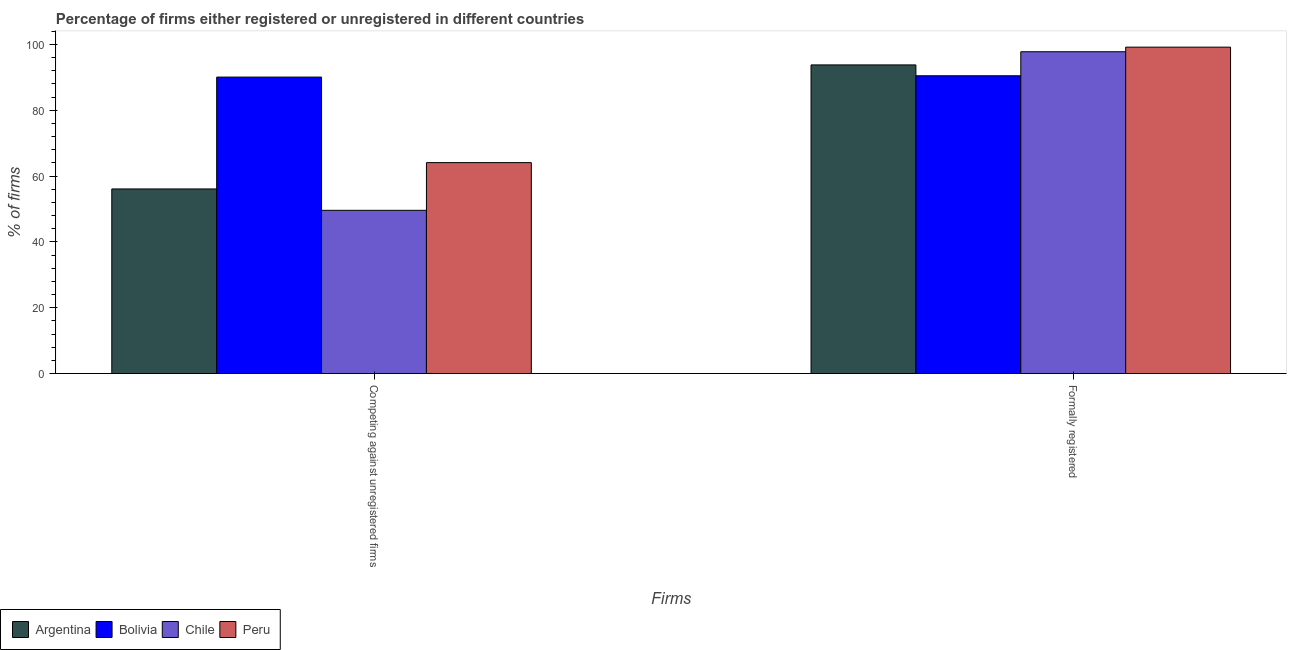How many different coloured bars are there?
Your answer should be very brief. 4. Are the number of bars per tick equal to the number of legend labels?
Your answer should be very brief. Yes. How many bars are there on the 1st tick from the right?
Give a very brief answer. 4. What is the label of the 1st group of bars from the left?
Offer a very short reply. Competing against unregistered firms. What is the percentage of formally registered firms in Argentina?
Give a very brief answer. 93.8. Across all countries, what is the maximum percentage of formally registered firms?
Provide a succinct answer. 99.2. Across all countries, what is the minimum percentage of registered firms?
Offer a terse response. 49.6. In which country was the percentage of formally registered firms maximum?
Ensure brevity in your answer.  Peru. What is the total percentage of formally registered firms in the graph?
Provide a succinct answer. 381.3. What is the difference between the percentage of formally registered firms in Bolivia and that in Chile?
Your response must be concise. -7.3. What is the difference between the percentage of registered firms in Argentina and the percentage of formally registered firms in Bolivia?
Your answer should be very brief. -34.4. What is the average percentage of registered firms per country?
Provide a succinct answer. 64.97. What is the difference between the percentage of registered firms and percentage of formally registered firms in Chile?
Offer a very short reply. -48.2. What is the ratio of the percentage of registered firms in Bolivia to that in Argentina?
Offer a very short reply. 1.61. Is the percentage of formally registered firms in Argentina less than that in Bolivia?
Keep it short and to the point. No. In how many countries, is the percentage of registered firms greater than the average percentage of registered firms taken over all countries?
Your answer should be very brief. 1. How many countries are there in the graph?
Ensure brevity in your answer.  4. What is the difference between two consecutive major ticks on the Y-axis?
Provide a short and direct response. 20. Does the graph contain any zero values?
Offer a terse response. No. Where does the legend appear in the graph?
Provide a short and direct response. Bottom left. How many legend labels are there?
Give a very brief answer. 4. What is the title of the graph?
Give a very brief answer. Percentage of firms either registered or unregistered in different countries. What is the label or title of the X-axis?
Give a very brief answer. Firms. What is the label or title of the Y-axis?
Ensure brevity in your answer.  % of firms. What is the % of firms in Argentina in Competing against unregistered firms?
Make the answer very short. 56.1. What is the % of firms in Bolivia in Competing against unregistered firms?
Provide a succinct answer. 90.1. What is the % of firms of Chile in Competing against unregistered firms?
Your answer should be very brief. 49.6. What is the % of firms in Peru in Competing against unregistered firms?
Keep it short and to the point. 64.1. What is the % of firms in Argentina in Formally registered?
Keep it short and to the point. 93.8. What is the % of firms of Bolivia in Formally registered?
Offer a terse response. 90.5. What is the % of firms in Chile in Formally registered?
Provide a short and direct response. 97.8. What is the % of firms of Peru in Formally registered?
Provide a succinct answer. 99.2. Across all Firms, what is the maximum % of firms in Argentina?
Ensure brevity in your answer.  93.8. Across all Firms, what is the maximum % of firms in Bolivia?
Offer a very short reply. 90.5. Across all Firms, what is the maximum % of firms in Chile?
Your answer should be compact. 97.8. Across all Firms, what is the maximum % of firms of Peru?
Your answer should be compact. 99.2. Across all Firms, what is the minimum % of firms of Argentina?
Your answer should be compact. 56.1. Across all Firms, what is the minimum % of firms in Bolivia?
Keep it short and to the point. 90.1. Across all Firms, what is the minimum % of firms of Chile?
Make the answer very short. 49.6. Across all Firms, what is the minimum % of firms of Peru?
Make the answer very short. 64.1. What is the total % of firms of Argentina in the graph?
Offer a terse response. 149.9. What is the total % of firms of Bolivia in the graph?
Your answer should be very brief. 180.6. What is the total % of firms in Chile in the graph?
Offer a terse response. 147.4. What is the total % of firms in Peru in the graph?
Keep it short and to the point. 163.3. What is the difference between the % of firms of Argentina in Competing against unregistered firms and that in Formally registered?
Your answer should be compact. -37.7. What is the difference between the % of firms in Bolivia in Competing against unregistered firms and that in Formally registered?
Provide a succinct answer. -0.4. What is the difference between the % of firms of Chile in Competing against unregistered firms and that in Formally registered?
Your response must be concise. -48.2. What is the difference between the % of firms in Peru in Competing against unregistered firms and that in Formally registered?
Keep it short and to the point. -35.1. What is the difference between the % of firms of Argentina in Competing against unregistered firms and the % of firms of Bolivia in Formally registered?
Your response must be concise. -34.4. What is the difference between the % of firms of Argentina in Competing against unregistered firms and the % of firms of Chile in Formally registered?
Give a very brief answer. -41.7. What is the difference between the % of firms of Argentina in Competing against unregistered firms and the % of firms of Peru in Formally registered?
Offer a terse response. -43.1. What is the difference between the % of firms in Chile in Competing against unregistered firms and the % of firms in Peru in Formally registered?
Your answer should be very brief. -49.6. What is the average % of firms in Argentina per Firms?
Offer a terse response. 74.95. What is the average % of firms of Bolivia per Firms?
Your answer should be very brief. 90.3. What is the average % of firms in Chile per Firms?
Your answer should be compact. 73.7. What is the average % of firms in Peru per Firms?
Offer a terse response. 81.65. What is the difference between the % of firms of Argentina and % of firms of Bolivia in Competing against unregistered firms?
Provide a short and direct response. -34. What is the difference between the % of firms in Bolivia and % of firms in Chile in Competing against unregistered firms?
Provide a short and direct response. 40.5. What is the difference between the % of firms in Bolivia and % of firms in Peru in Competing against unregistered firms?
Your response must be concise. 26. What is the difference between the % of firms in Chile and % of firms in Peru in Competing against unregistered firms?
Offer a terse response. -14.5. What is the difference between the % of firms of Argentina and % of firms of Bolivia in Formally registered?
Offer a very short reply. 3.3. What is the difference between the % of firms of Argentina and % of firms of Chile in Formally registered?
Provide a short and direct response. -4. What is the difference between the % of firms in Argentina and % of firms in Peru in Formally registered?
Offer a terse response. -5.4. What is the difference between the % of firms in Bolivia and % of firms in Chile in Formally registered?
Your answer should be compact. -7.3. What is the difference between the % of firms of Bolivia and % of firms of Peru in Formally registered?
Keep it short and to the point. -8.7. What is the difference between the % of firms in Chile and % of firms in Peru in Formally registered?
Ensure brevity in your answer.  -1.4. What is the ratio of the % of firms in Argentina in Competing against unregistered firms to that in Formally registered?
Ensure brevity in your answer.  0.6. What is the ratio of the % of firms of Bolivia in Competing against unregistered firms to that in Formally registered?
Give a very brief answer. 1. What is the ratio of the % of firms in Chile in Competing against unregistered firms to that in Formally registered?
Provide a short and direct response. 0.51. What is the ratio of the % of firms in Peru in Competing against unregistered firms to that in Formally registered?
Offer a very short reply. 0.65. What is the difference between the highest and the second highest % of firms of Argentina?
Offer a very short reply. 37.7. What is the difference between the highest and the second highest % of firms in Bolivia?
Offer a very short reply. 0.4. What is the difference between the highest and the second highest % of firms of Chile?
Make the answer very short. 48.2. What is the difference between the highest and the second highest % of firms in Peru?
Your answer should be very brief. 35.1. What is the difference between the highest and the lowest % of firms in Argentina?
Make the answer very short. 37.7. What is the difference between the highest and the lowest % of firms of Bolivia?
Your answer should be compact. 0.4. What is the difference between the highest and the lowest % of firms in Chile?
Offer a terse response. 48.2. What is the difference between the highest and the lowest % of firms in Peru?
Provide a succinct answer. 35.1. 